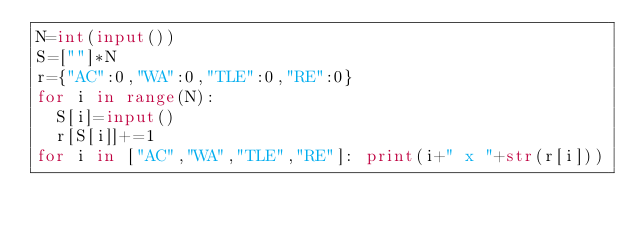<code> <loc_0><loc_0><loc_500><loc_500><_Python_>N=int(input())
S=[""]*N
r={"AC":0,"WA":0,"TLE":0,"RE":0}
for i in range(N): 
  S[i]=input()
  r[S[i]]+=1
for i in ["AC","WA","TLE","RE"]: print(i+" x "+str(r[i]))</code> 